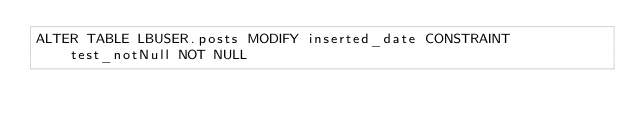Convert code to text. <code><loc_0><loc_0><loc_500><loc_500><_SQL_>ALTER TABLE LBUSER.posts MODIFY inserted_date CONSTRAINT test_notNull NOT NULL</code> 